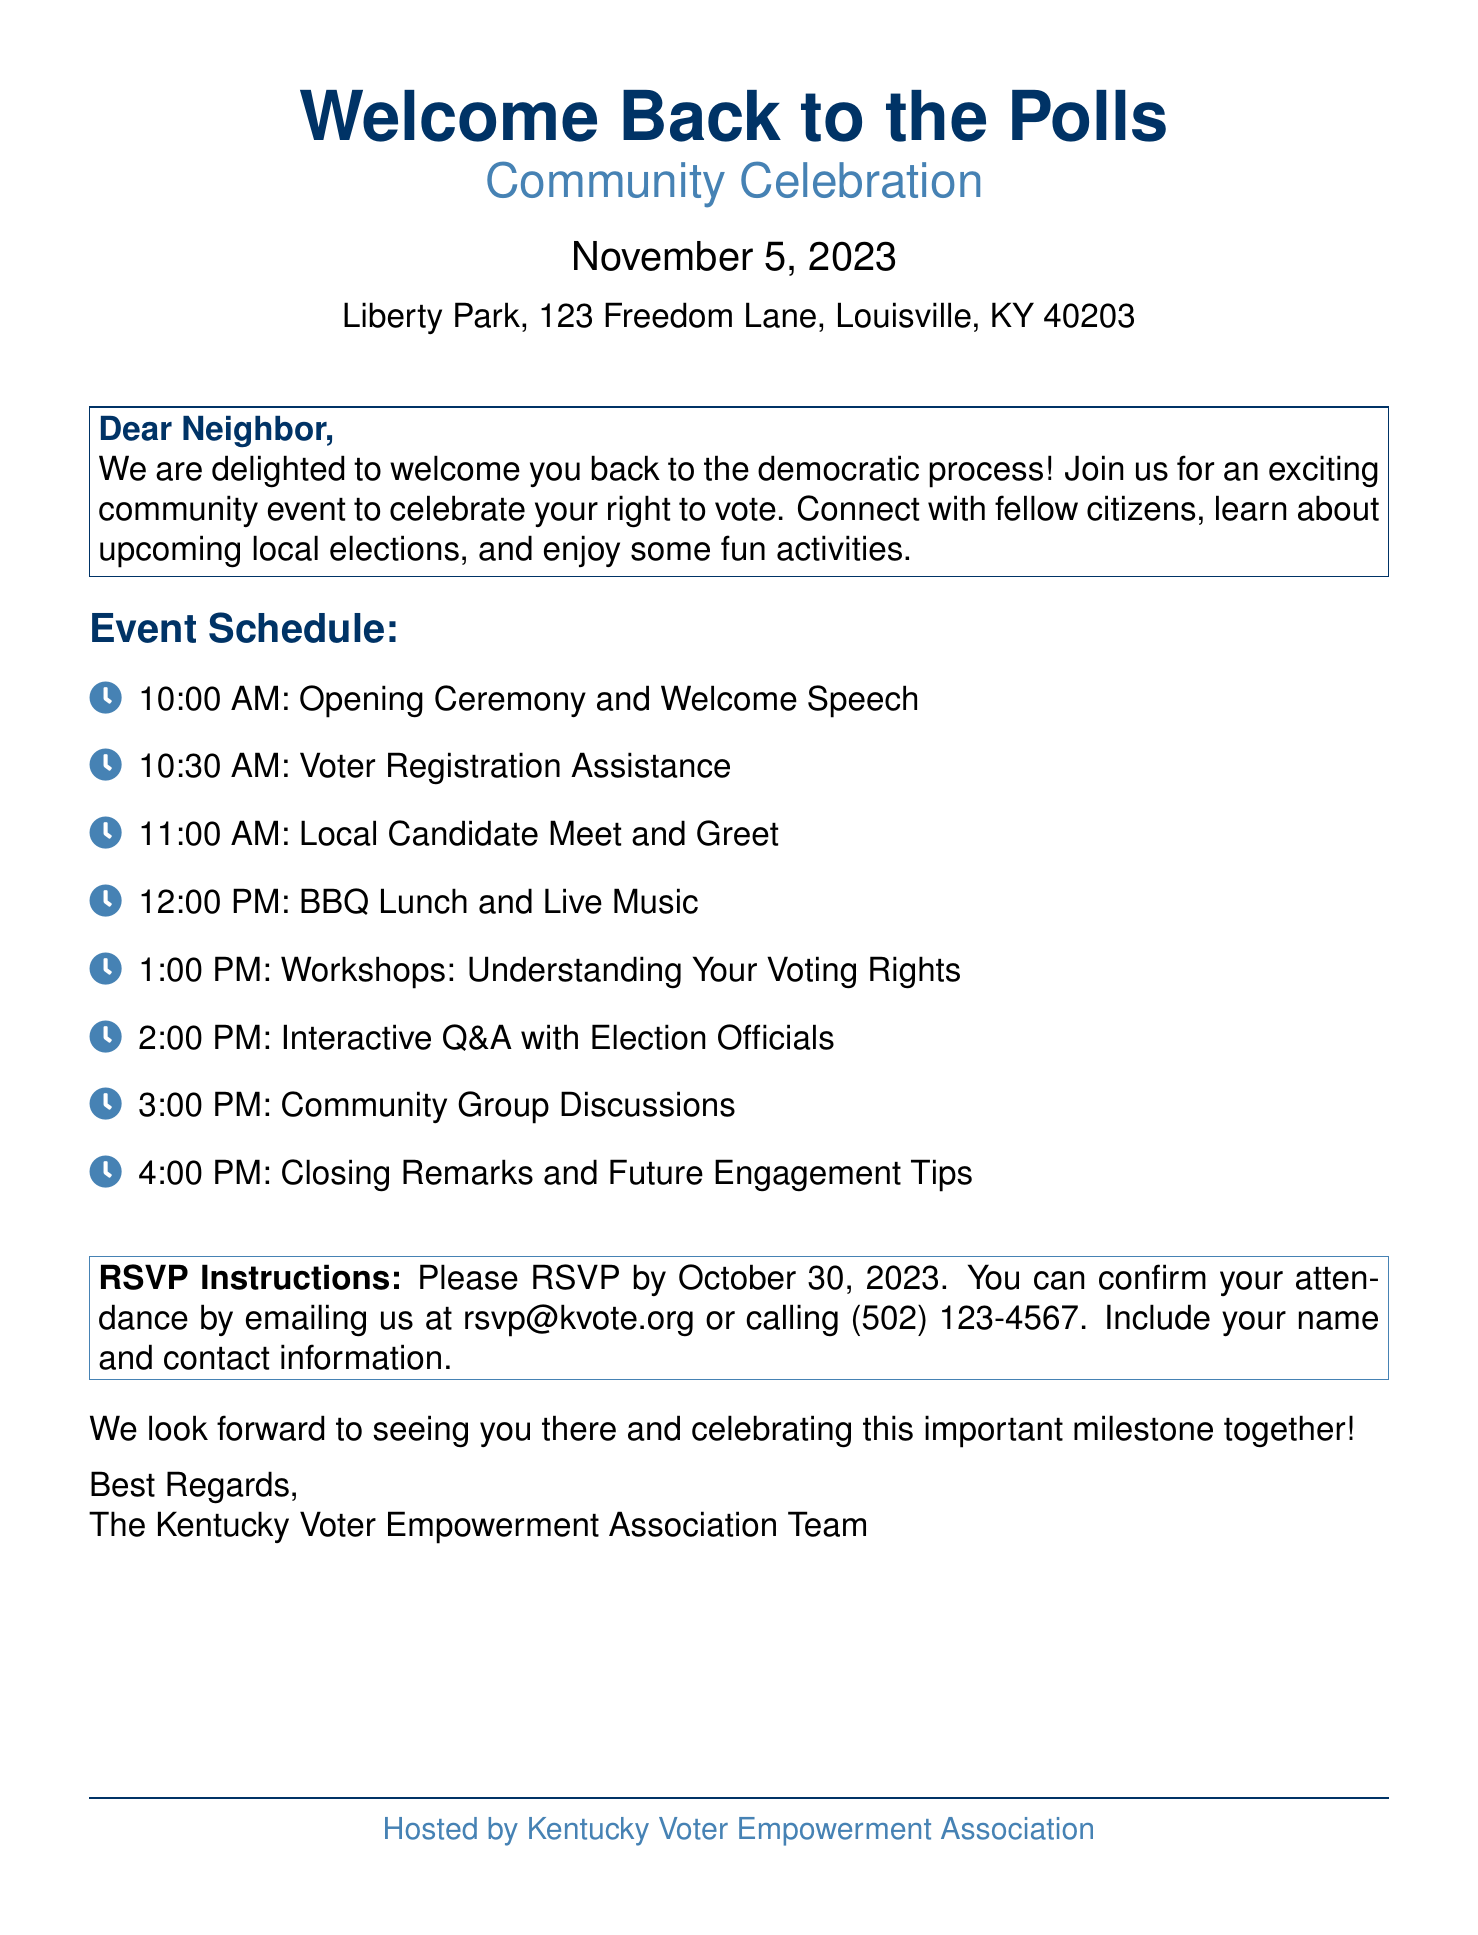What is the date of the event? The date of the event is explicitly stated in the document as November 5, 2023.
Answer: November 5, 2023 Where is the event located? The location of the event is given as Liberty Park, 123 Freedom Lane, Louisville, KY 40203.
Answer: Liberty Park, 123 Freedom Lane, Louisville, KY 40203 What time does the closing remarks start? The schedule lists the closing remarks starting at 4:00 PM.
Answer: 4:00 PM When is the RSVP deadline? The deadline for RSVPs is indicated as October 30, 2023.
Answer: October 30, 2023 What is the first activity in the event schedule? The first activity listed in the event schedule is the Opening Ceremony and Welcome Speech at 10:00 AM.
Answer: Opening Ceremony and Welcome Speech How can attendees RSVP? The document provides two options for RSVPing: email and phone.
Answer: Email or phone What type of event is being celebrated? The document outlines the event as a celebration of the right to vote.
Answer: Right to vote Who is hosting the event? The hosting organization is mentioned at the bottom of the document.
Answer: Kentucky Voter Empowerment Association 